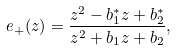<formula> <loc_0><loc_0><loc_500><loc_500>e _ { + } ( z ) = \frac { z ^ { 2 } - b _ { 1 } ^ { * } z + b _ { 2 } ^ { * } } { z ^ { 2 } + b _ { 1 } z + b _ { 2 } } ,</formula> 